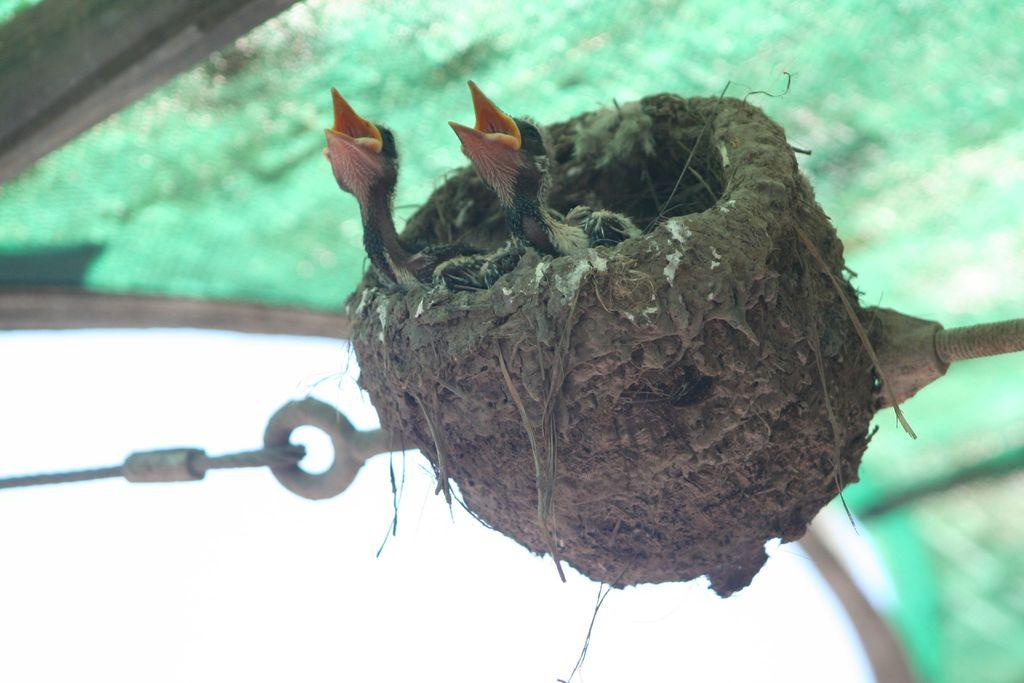What type of animals are in the nest in the image? There are two birds in a nest in the image. Can you describe the metal objects in the image? Unfortunately, we do not have enough information to describe the metal objects in the image. How many chickens are in the image? There are no chickens present in the image; it features two birds in a nest. Can you describe the lipstick shade worn by the bird in the image? There is no mention of lipstick or any bird wearing makeup in the image. 